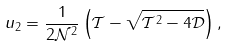<formula> <loc_0><loc_0><loc_500><loc_500>u _ { 2 } = \frac { 1 } { 2 \mathcal { N } ^ { 2 } } \left ( \mathcal { T } - \sqrt { \mathcal { T } ^ { 2 } - 4 \mathcal { D } } \right ) ,</formula> 